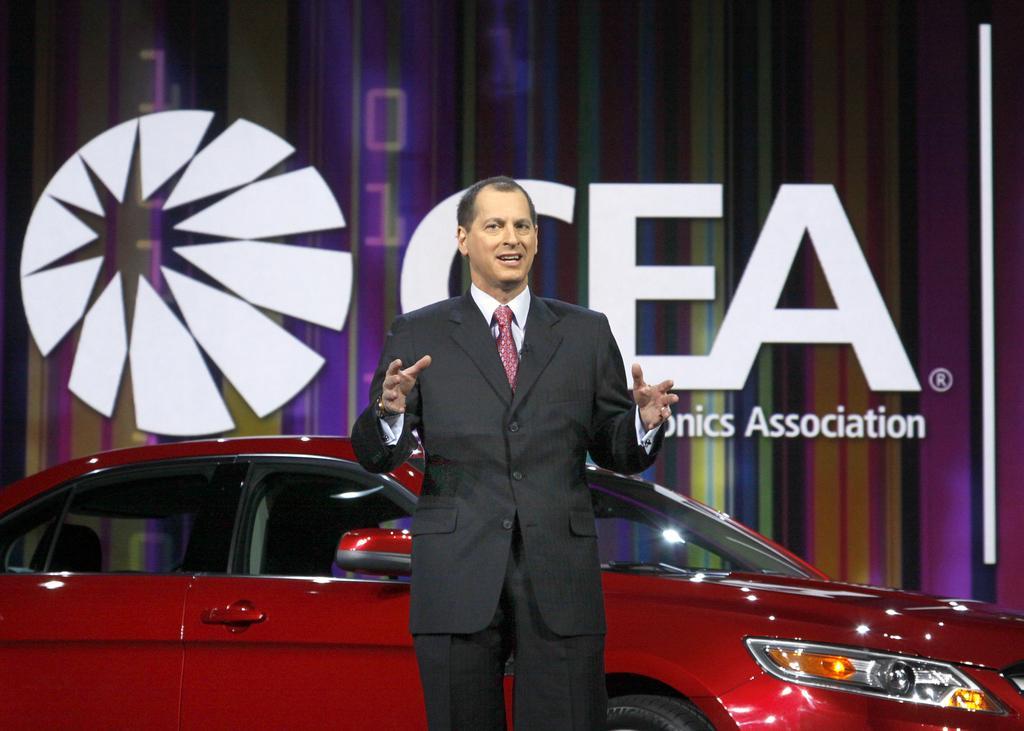How would you summarize this image in a sentence or two? In this image there is one person standing and wearing a blazer in the middle of this image. There is a red color car in the bottom of this image and there is a wall in the background,and there is a logo with some text in the background. 